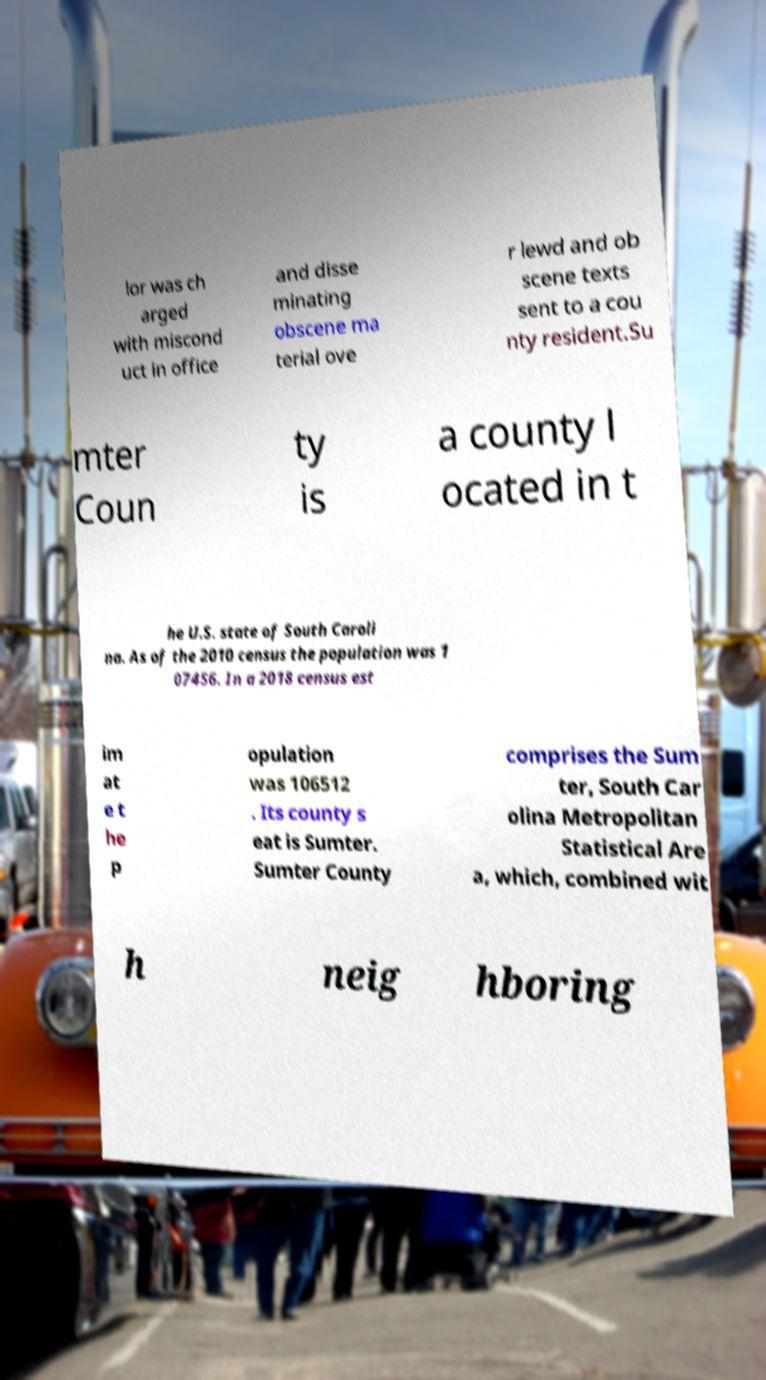Please read and relay the text visible in this image. What does it say? lor was ch arged with miscond uct in office and disse minating obscene ma terial ove r lewd and ob scene texts sent to a cou nty resident.Su mter Coun ty is a county l ocated in t he U.S. state of South Caroli na. As of the 2010 census the population was 1 07456. In a 2018 census est im at e t he p opulation was 106512 . Its county s eat is Sumter. Sumter County comprises the Sum ter, South Car olina Metropolitan Statistical Are a, which, combined wit h neig hboring 